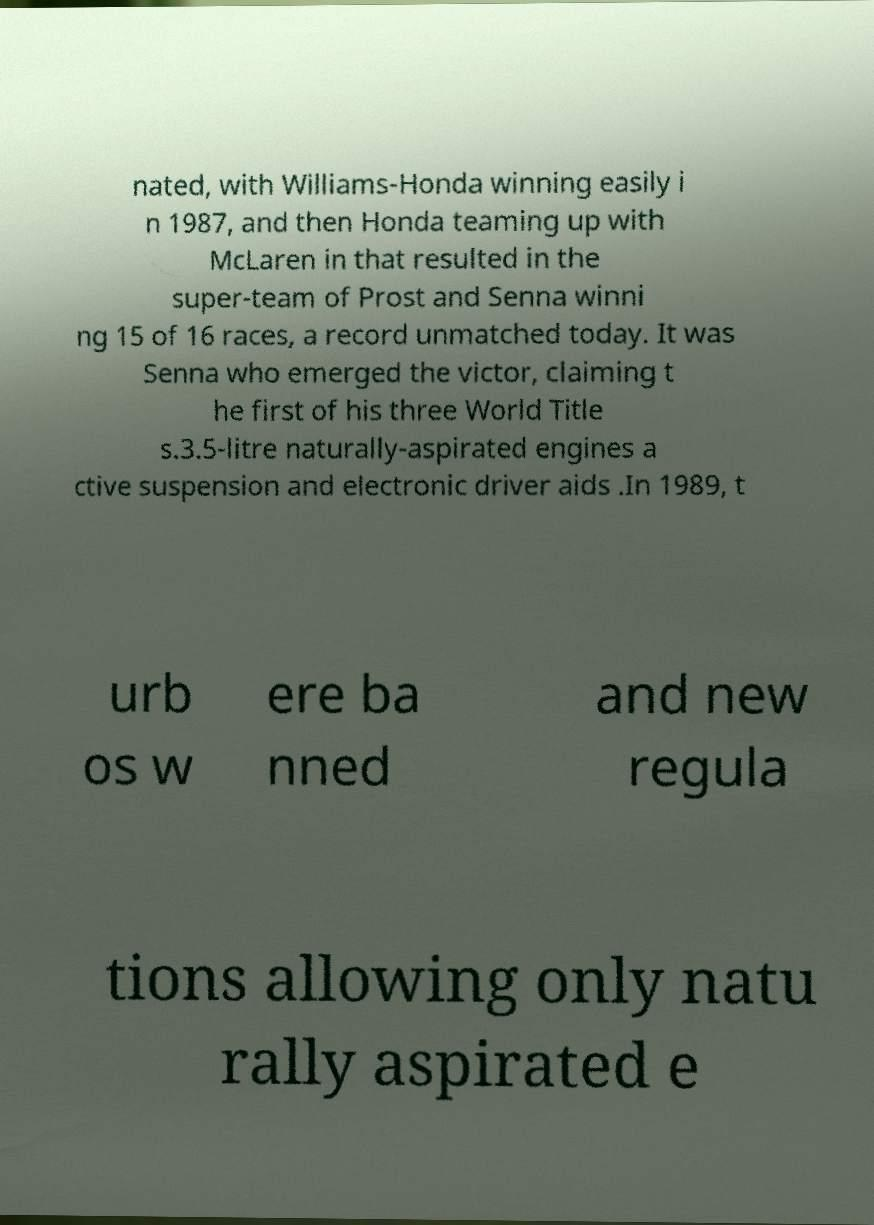Could you extract and type out the text from this image? nated, with Williams-Honda winning easily i n 1987, and then Honda teaming up with McLaren in that resulted in the super-team of Prost and Senna winni ng 15 of 16 races, a record unmatched today. It was Senna who emerged the victor, claiming t he first of his three World Title s.3.5-litre naturally-aspirated engines a ctive suspension and electronic driver aids .In 1989, t urb os w ere ba nned and new regula tions allowing only natu rally aspirated e 